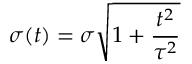Convert formula to latex. <formula><loc_0><loc_0><loc_500><loc_500>\sigma ( t ) = \sigma \sqrt { 1 + \frac { t ^ { 2 } } { \tau ^ { 2 } } }</formula> 